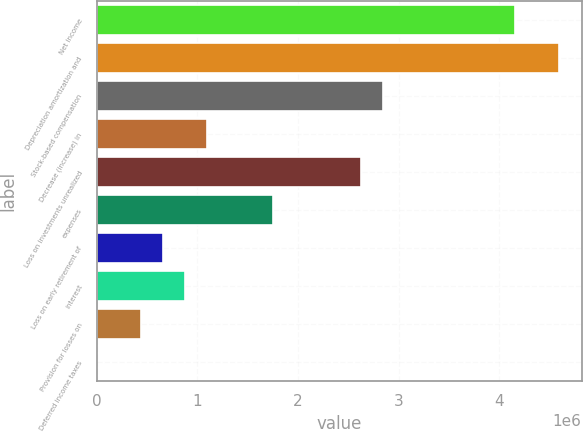<chart> <loc_0><loc_0><loc_500><loc_500><bar_chart><fcel>Net income<fcel>Depreciation amortization and<fcel>Stock-based compensation<fcel>Decrease (increase) in<fcel>Loss on investments unrealized<fcel>expenses<fcel>Loss on early retirement of<fcel>interest<fcel>Provision for losses on<fcel>Deferred income taxes<nl><fcel>4.15405e+06<fcel>4.59118e+06<fcel>2.84268e+06<fcel>1.09419e+06<fcel>2.62412e+06<fcel>1.74988e+06<fcel>657069<fcel>875630<fcel>438507<fcel>1384<nl></chart> 